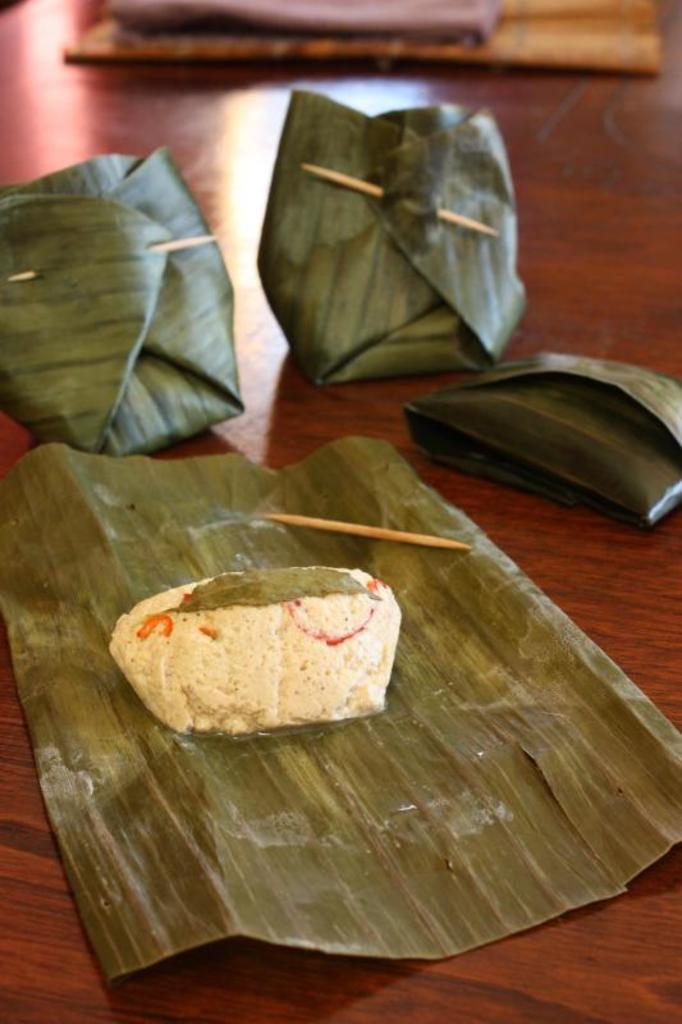What is the main subject of the image? The main subject of the image is a food item on a leaf. Are there any other items in the image? Yes, there are other items wrapped and sealed with toothpicks in the leaves around the leaf with the food item. What type of shoes can be seen in the image? There are no shoes present in the image. What emotion is the food item expressing in the image? Food items do not have emotions, so this question cannot be answered. 